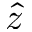Convert formula to latex. <formula><loc_0><loc_0><loc_500><loc_500>\hat { z }</formula> 